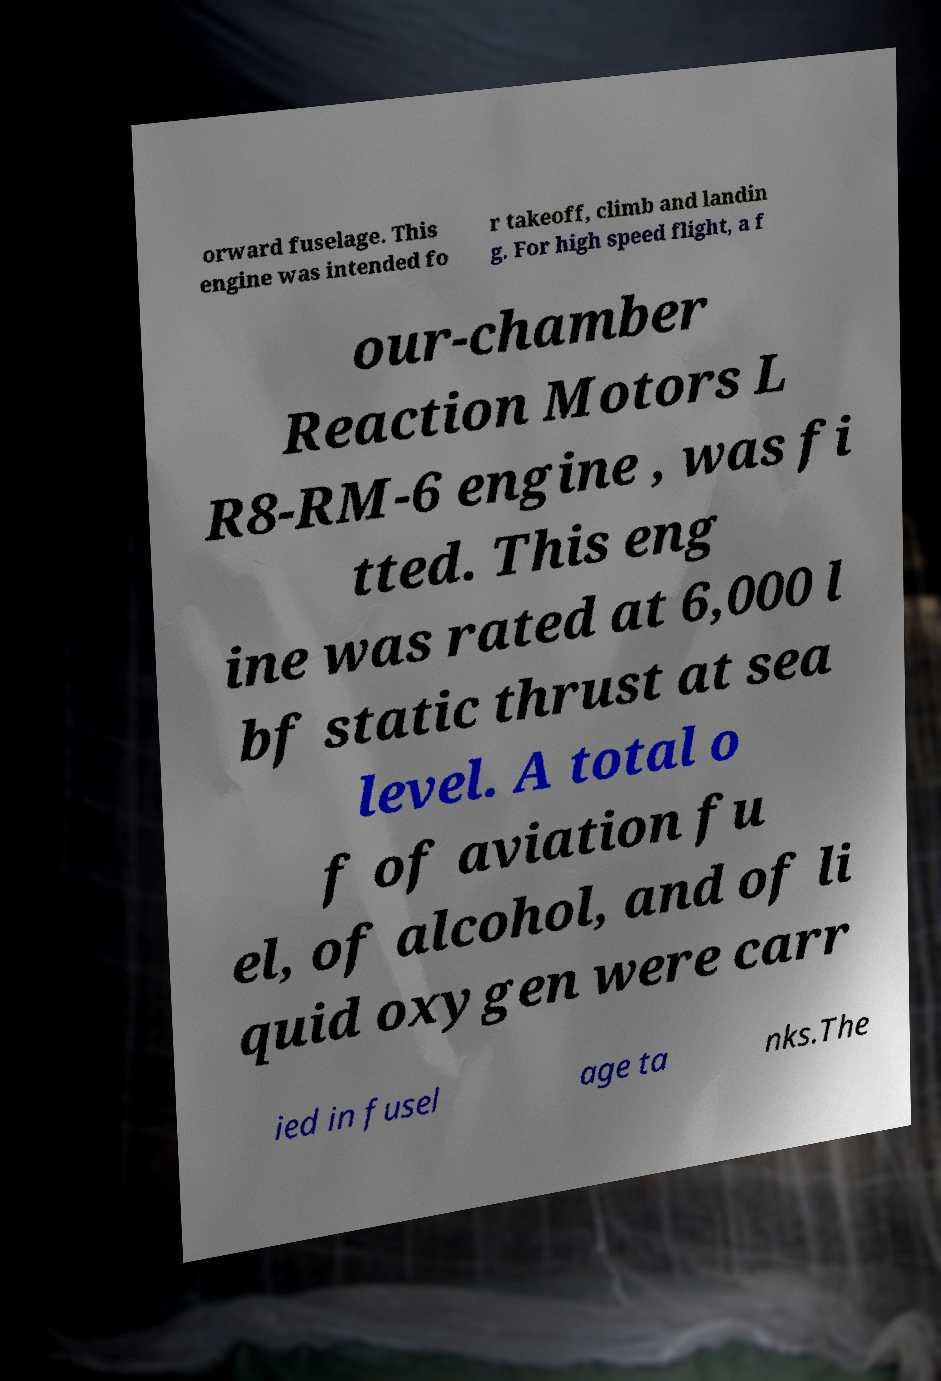I need the written content from this picture converted into text. Can you do that? orward fuselage. This engine was intended fo r takeoff, climb and landin g. For high speed flight, a f our-chamber Reaction Motors L R8-RM-6 engine , was fi tted. This eng ine was rated at 6,000 l bf static thrust at sea level. A total o f of aviation fu el, of alcohol, and of li quid oxygen were carr ied in fusel age ta nks.The 